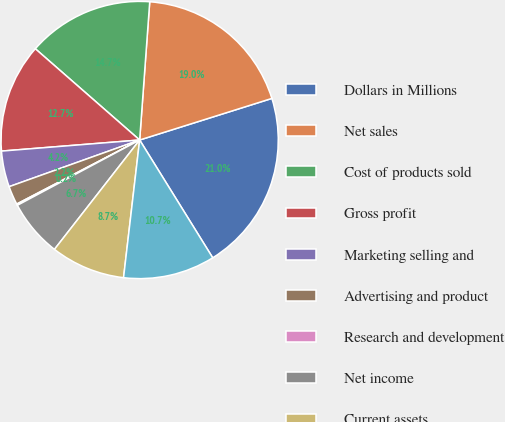Convert chart. <chart><loc_0><loc_0><loc_500><loc_500><pie_chart><fcel>Dollars in Millions<fcel>Net sales<fcel>Cost of products sold<fcel>Gross profit<fcel>Marketing selling and<fcel>Advertising and product<fcel>Research and development<fcel>Net income<fcel>Current assets<fcel>Current liabilities<nl><fcel>21.01%<fcel>18.99%<fcel>14.72%<fcel>12.71%<fcel>4.19%<fcel>2.18%<fcel>0.16%<fcel>6.66%<fcel>8.68%<fcel>10.69%<nl></chart> 